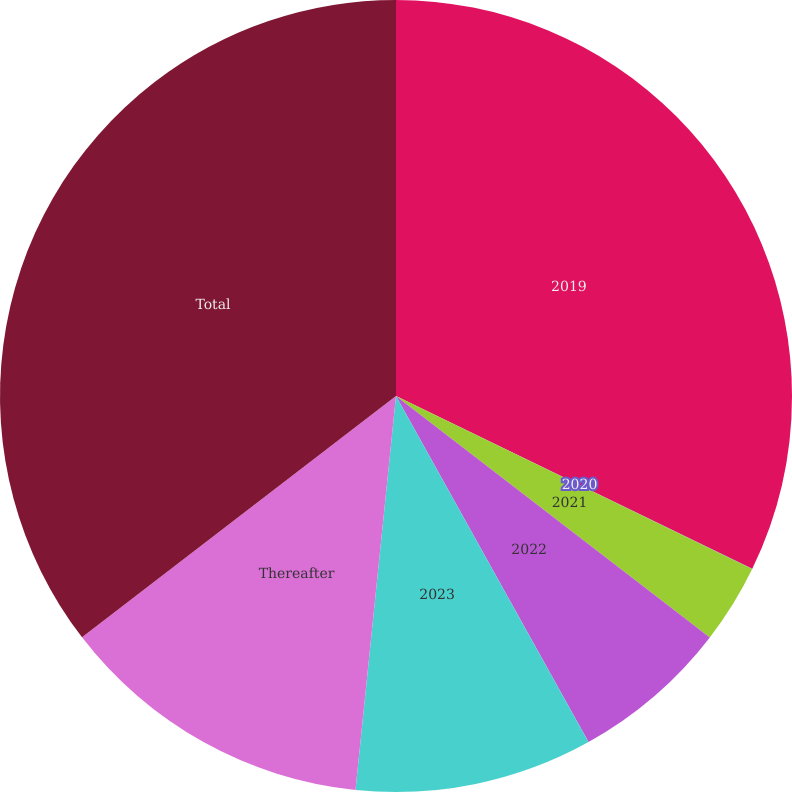<chart> <loc_0><loc_0><loc_500><loc_500><pie_chart><fcel>2019<fcel>2020<fcel>2021<fcel>2022<fcel>2023<fcel>Thereafter<fcel>Total<nl><fcel>32.19%<fcel>0.01%<fcel>3.24%<fcel>6.48%<fcel>9.71%<fcel>12.94%<fcel>35.43%<nl></chart> 